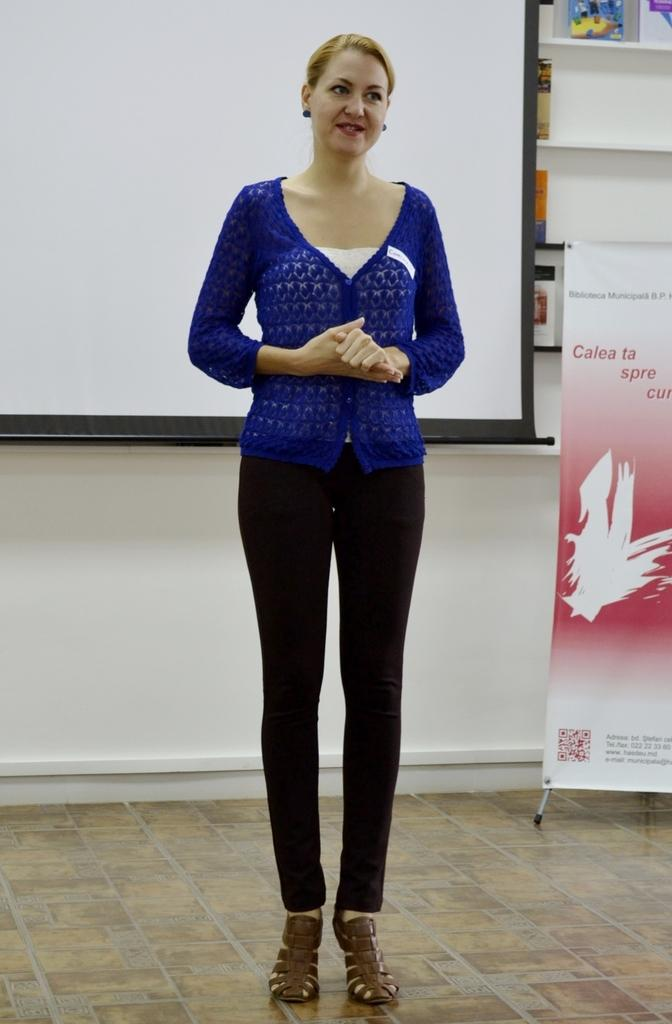What is the main subject in the image? There is a lady standing in the image. What is behind the lady? There is a screen behind the lady. What can be seen in the right corner of the image? There is a banner in the right corner of the image. What is located behind the banner? There are racks with items behind the banner. What type of mist can be seen surrounding the lady in the image? There is no mist present in the image; it is a clear scene with the lady standing in front of a screen. 